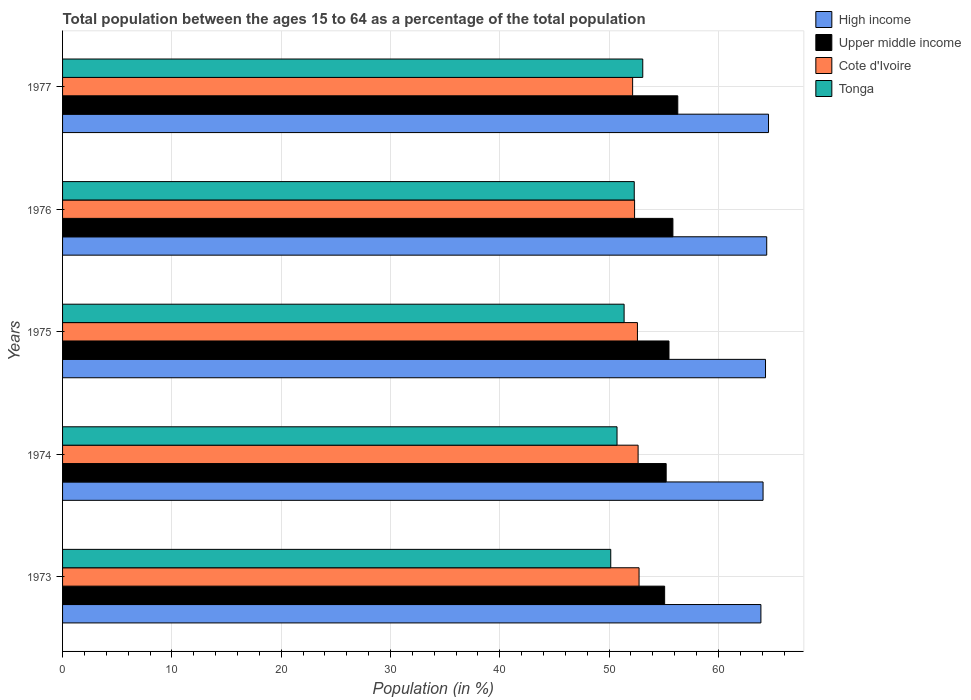How many different coloured bars are there?
Ensure brevity in your answer.  4. How many groups of bars are there?
Keep it short and to the point. 5. Are the number of bars on each tick of the Y-axis equal?
Your answer should be compact. Yes. How many bars are there on the 2nd tick from the top?
Your response must be concise. 4. How many bars are there on the 3rd tick from the bottom?
Your answer should be very brief. 4. What is the label of the 3rd group of bars from the top?
Offer a terse response. 1975. What is the percentage of the population ages 15 to 64 in High income in 1973?
Offer a terse response. 63.89. Across all years, what is the maximum percentage of the population ages 15 to 64 in Cote d'Ivoire?
Your answer should be very brief. 52.74. Across all years, what is the minimum percentage of the population ages 15 to 64 in Cote d'Ivoire?
Give a very brief answer. 52.15. In which year was the percentage of the population ages 15 to 64 in Tonga maximum?
Make the answer very short. 1977. What is the total percentage of the population ages 15 to 64 in High income in the graph?
Give a very brief answer. 321.27. What is the difference between the percentage of the population ages 15 to 64 in Tonga in 1975 and that in 1977?
Your answer should be compact. -1.71. What is the difference between the percentage of the population ages 15 to 64 in Upper middle income in 1973 and the percentage of the population ages 15 to 64 in Cote d'Ivoire in 1976?
Provide a succinct answer. 2.75. What is the average percentage of the population ages 15 to 64 in Upper middle income per year?
Make the answer very short. 55.58. In the year 1975, what is the difference between the percentage of the population ages 15 to 64 in High income and percentage of the population ages 15 to 64 in Tonga?
Offer a very short reply. 12.94. In how many years, is the percentage of the population ages 15 to 64 in Upper middle income greater than 46 ?
Offer a terse response. 5. What is the ratio of the percentage of the population ages 15 to 64 in High income in 1973 to that in 1976?
Provide a succinct answer. 0.99. Is the percentage of the population ages 15 to 64 in Tonga in 1973 less than that in 1974?
Provide a succinct answer. Yes. What is the difference between the highest and the second highest percentage of the population ages 15 to 64 in High income?
Your response must be concise. 0.16. What is the difference between the highest and the lowest percentage of the population ages 15 to 64 in High income?
Provide a short and direct response. 0.7. In how many years, is the percentage of the population ages 15 to 64 in Cote d'Ivoire greater than the average percentage of the population ages 15 to 64 in Cote d'Ivoire taken over all years?
Keep it short and to the point. 3. Is the sum of the percentage of the population ages 15 to 64 in High income in 1973 and 1977 greater than the maximum percentage of the population ages 15 to 64 in Cote d'Ivoire across all years?
Your response must be concise. Yes. What does the 1st bar from the top in 1976 represents?
Ensure brevity in your answer.  Tonga. What does the 4th bar from the bottom in 1976 represents?
Give a very brief answer. Tonga. How many bars are there?
Provide a succinct answer. 20. Are the values on the major ticks of X-axis written in scientific E-notation?
Provide a short and direct response. No. Does the graph contain any zero values?
Ensure brevity in your answer.  No. Does the graph contain grids?
Offer a terse response. Yes. How are the legend labels stacked?
Make the answer very short. Vertical. What is the title of the graph?
Your answer should be compact. Total population between the ages 15 to 64 as a percentage of the total population. What is the label or title of the X-axis?
Offer a terse response. Population (in %). What is the Population (in %) in High income in 1973?
Your answer should be compact. 63.89. What is the Population (in %) of Upper middle income in 1973?
Offer a terse response. 55.08. What is the Population (in %) of Cote d'Ivoire in 1973?
Offer a terse response. 52.74. What is the Population (in %) in Tonga in 1973?
Keep it short and to the point. 50.15. What is the Population (in %) of High income in 1974?
Make the answer very short. 64.08. What is the Population (in %) of Upper middle income in 1974?
Your answer should be compact. 55.22. What is the Population (in %) in Cote d'Ivoire in 1974?
Offer a terse response. 52.65. What is the Population (in %) in Tonga in 1974?
Provide a succinct answer. 50.72. What is the Population (in %) of High income in 1975?
Ensure brevity in your answer.  64.31. What is the Population (in %) of Upper middle income in 1975?
Your answer should be compact. 55.48. What is the Population (in %) of Cote d'Ivoire in 1975?
Your response must be concise. 52.59. What is the Population (in %) in Tonga in 1975?
Make the answer very short. 51.37. What is the Population (in %) in High income in 1976?
Your answer should be very brief. 64.42. What is the Population (in %) in Upper middle income in 1976?
Your response must be concise. 55.83. What is the Population (in %) of Cote d'Ivoire in 1976?
Make the answer very short. 52.33. What is the Population (in %) in Tonga in 1976?
Provide a succinct answer. 52.3. What is the Population (in %) of High income in 1977?
Ensure brevity in your answer.  64.58. What is the Population (in %) in Upper middle income in 1977?
Your answer should be very brief. 56.28. What is the Population (in %) in Cote d'Ivoire in 1977?
Provide a succinct answer. 52.15. What is the Population (in %) in Tonga in 1977?
Make the answer very short. 53.08. Across all years, what is the maximum Population (in %) of High income?
Keep it short and to the point. 64.58. Across all years, what is the maximum Population (in %) in Upper middle income?
Your response must be concise. 56.28. Across all years, what is the maximum Population (in %) in Cote d'Ivoire?
Offer a terse response. 52.74. Across all years, what is the maximum Population (in %) of Tonga?
Keep it short and to the point. 53.08. Across all years, what is the minimum Population (in %) of High income?
Make the answer very short. 63.89. Across all years, what is the minimum Population (in %) in Upper middle income?
Provide a succinct answer. 55.08. Across all years, what is the minimum Population (in %) in Cote d'Ivoire?
Give a very brief answer. 52.15. Across all years, what is the minimum Population (in %) in Tonga?
Provide a short and direct response. 50.15. What is the total Population (in %) of High income in the graph?
Provide a short and direct response. 321.27. What is the total Population (in %) of Upper middle income in the graph?
Your answer should be very brief. 277.89. What is the total Population (in %) of Cote d'Ivoire in the graph?
Keep it short and to the point. 262.46. What is the total Population (in %) in Tonga in the graph?
Make the answer very short. 257.62. What is the difference between the Population (in %) in High income in 1973 and that in 1974?
Your answer should be very brief. -0.2. What is the difference between the Population (in %) of Upper middle income in 1973 and that in 1974?
Your answer should be compact. -0.14. What is the difference between the Population (in %) in Cote d'Ivoire in 1973 and that in 1974?
Ensure brevity in your answer.  0.09. What is the difference between the Population (in %) of Tonga in 1973 and that in 1974?
Provide a succinct answer. -0.57. What is the difference between the Population (in %) of High income in 1973 and that in 1975?
Provide a short and direct response. -0.42. What is the difference between the Population (in %) of Upper middle income in 1973 and that in 1975?
Provide a succinct answer. -0.4. What is the difference between the Population (in %) of Cote d'Ivoire in 1973 and that in 1975?
Provide a succinct answer. 0.15. What is the difference between the Population (in %) in Tonga in 1973 and that in 1975?
Your response must be concise. -1.22. What is the difference between the Population (in %) in High income in 1973 and that in 1976?
Ensure brevity in your answer.  -0.53. What is the difference between the Population (in %) of Upper middle income in 1973 and that in 1976?
Your answer should be compact. -0.76. What is the difference between the Population (in %) of Cote d'Ivoire in 1973 and that in 1976?
Provide a short and direct response. 0.41. What is the difference between the Population (in %) in Tonga in 1973 and that in 1976?
Your answer should be very brief. -2.15. What is the difference between the Population (in %) of High income in 1973 and that in 1977?
Give a very brief answer. -0.7. What is the difference between the Population (in %) of Upper middle income in 1973 and that in 1977?
Provide a short and direct response. -1.2. What is the difference between the Population (in %) in Cote d'Ivoire in 1973 and that in 1977?
Offer a very short reply. 0.59. What is the difference between the Population (in %) of Tonga in 1973 and that in 1977?
Ensure brevity in your answer.  -2.93. What is the difference between the Population (in %) in High income in 1974 and that in 1975?
Your answer should be very brief. -0.22. What is the difference between the Population (in %) in Upper middle income in 1974 and that in 1975?
Keep it short and to the point. -0.26. What is the difference between the Population (in %) in Cote d'Ivoire in 1974 and that in 1975?
Ensure brevity in your answer.  0.06. What is the difference between the Population (in %) of Tonga in 1974 and that in 1975?
Provide a succinct answer. -0.65. What is the difference between the Population (in %) of High income in 1974 and that in 1976?
Your response must be concise. -0.33. What is the difference between the Population (in %) in Upper middle income in 1974 and that in 1976?
Offer a terse response. -0.62. What is the difference between the Population (in %) in Cote d'Ivoire in 1974 and that in 1976?
Offer a terse response. 0.32. What is the difference between the Population (in %) in Tonga in 1974 and that in 1976?
Your answer should be very brief. -1.58. What is the difference between the Population (in %) in High income in 1974 and that in 1977?
Provide a succinct answer. -0.5. What is the difference between the Population (in %) in Upper middle income in 1974 and that in 1977?
Give a very brief answer. -1.06. What is the difference between the Population (in %) of Cote d'Ivoire in 1974 and that in 1977?
Your answer should be very brief. 0.5. What is the difference between the Population (in %) of Tonga in 1974 and that in 1977?
Ensure brevity in your answer.  -2.35. What is the difference between the Population (in %) in High income in 1975 and that in 1976?
Give a very brief answer. -0.11. What is the difference between the Population (in %) of Upper middle income in 1975 and that in 1976?
Your answer should be very brief. -0.36. What is the difference between the Population (in %) in Cote d'Ivoire in 1975 and that in 1976?
Provide a short and direct response. 0.26. What is the difference between the Population (in %) of Tonga in 1975 and that in 1976?
Provide a short and direct response. -0.93. What is the difference between the Population (in %) in High income in 1975 and that in 1977?
Make the answer very short. -0.28. What is the difference between the Population (in %) in Upper middle income in 1975 and that in 1977?
Provide a succinct answer. -0.81. What is the difference between the Population (in %) of Cote d'Ivoire in 1975 and that in 1977?
Your answer should be very brief. 0.44. What is the difference between the Population (in %) of Tonga in 1975 and that in 1977?
Your answer should be very brief. -1.71. What is the difference between the Population (in %) in High income in 1976 and that in 1977?
Offer a very short reply. -0.16. What is the difference between the Population (in %) of Upper middle income in 1976 and that in 1977?
Your answer should be compact. -0.45. What is the difference between the Population (in %) in Cote d'Ivoire in 1976 and that in 1977?
Your answer should be very brief. 0.18. What is the difference between the Population (in %) of Tonga in 1976 and that in 1977?
Make the answer very short. -0.78. What is the difference between the Population (in %) of High income in 1973 and the Population (in %) of Upper middle income in 1974?
Keep it short and to the point. 8.67. What is the difference between the Population (in %) of High income in 1973 and the Population (in %) of Cote d'Ivoire in 1974?
Offer a terse response. 11.23. What is the difference between the Population (in %) in High income in 1973 and the Population (in %) in Tonga in 1974?
Make the answer very short. 13.16. What is the difference between the Population (in %) in Upper middle income in 1973 and the Population (in %) in Cote d'Ivoire in 1974?
Provide a succinct answer. 2.43. What is the difference between the Population (in %) in Upper middle income in 1973 and the Population (in %) in Tonga in 1974?
Make the answer very short. 4.36. What is the difference between the Population (in %) in Cote d'Ivoire in 1973 and the Population (in %) in Tonga in 1974?
Offer a terse response. 2.02. What is the difference between the Population (in %) of High income in 1973 and the Population (in %) of Upper middle income in 1975?
Keep it short and to the point. 8.41. What is the difference between the Population (in %) of High income in 1973 and the Population (in %) of Cote d'Ivoire in 1975?
Provide a short and direct response. 11.3. What is the difference between the Population (in %) of High income in 1973 and the Population (in %) of Tonga in 1975?
Your answer should be compact. 12.51. What is the difference between the Population (in %) in Upper middle income in 1973 and the Population (in %) in Cote d'Ivoire in 1975?
Make the answer very short. 2.49. What is the difference between the Population (in %) of Upper middle income in 1973 and the Population (in %) of Tonga in 1975?
Make the answer very short. 3.71. What is the difference between the Population (in %) in Cote d'Ivoire in 1973 and the Population (in %) in Tonga in 1975?
Your answer should be compact. 1.37. What is the difference between the Population (in %) in High income in 1973 and the Population (in %) in Upper middle income in 1976?
Give a very brief answer. 8.05. What is the difference between the Population (in %) of High income in 1973 and the Population (in %) of Cote d'Ivoire in 1976?
Give a very brief answer. 11.56. What is the difference between the Population (in %) of High income in 1973 and the Population (in %) of Tonga in 1976?
Your answer should be very brief. 11.59. What is the difference between the Population (in %) in Upper middle income in 1973 and the Population (in %) in Cote d'Ivoire in 1976?
Your response must be concise. 2.75. What is the difference between the Population (in %) in Upper middle income in 1973 and the Population (in %) in Tonga in 1976?
Offer a very short reply. 2.78. What is the difference between the Population (in %) in Cote d'Ivoire in 1973 and the Population (in %) in Tonga in 1976?
Offer a terse response. 0.44. What is the difference between the Population (in %) of High income in 1973 and the Population (in %) of Upper middle income in 1977?
Provide a short and direct response. 7.6. What is the difference between the Population (in %) in High income in 1973 and the Population (in %) in Cote d'Ivoire in 1977?
Keep it short and to the point. 11.74. What is the difference between the Population (in %) in High income in 1973 and the Population (in %) in Tonga in 1977?
Your answer should be compact. 10.81. What is the difference between the Population (in %) in Upper middle income in 1973 and the Population (in %) in Cote d'Ivoire in 1977?
Your answer should be compact. 2.93. What is the difference between the Population (in %) in Upper middle income in 1973 and the Population (in %) in Tonga in 1977?
Give a very brief answer. 2. What is the difference between the Population (in %) of Cote d'Ivoire in 1973 and the Population (in %) of Tonga in 1977?
Your answer should be compact. -0.34. What is the difference between the Population (in %) in High income in 1974 and the Population (in %) in Upper middle income in 1975?
Keep it short and to the point. 8.61. What is the difference between the Population (in %) in High income in 1974 and the Population (in %) in Cote d'Ivoire in 1975?
Ensure brevity in your answer.  11.49. What is the difference between the Population (in %) of High income in 1974 and the Population (in %) of Tonga in 1975?
Make the answer very short. 12.71. What is the difference between the Population (in %) in Upper middle income in 1974 and the Population (in %) in Cote d'Ivoire in 1975?
Provide a short and direct response. 2.63. What is the difference between the Population (in %) of Upper middle income in 1974 and the Population (in %) of Tonga in 1975?
Make the answer very short. 3.85. What is the difference between the Population (in %) of Cote d'Ivoire in 1974 and the Population (in %) of Tonga in 1975?
Your answer should be compact. 1.28. What is the difference between the Population (in %) in High income in 1974 and the Population (in %) in Upper middle income in 1976?
Provide a short and direct response. 8.25. What is the difference between the Population (in %) of High income in 1974 and the Population (in %) of Cote d'Ivoire in 1976?
Provide a succinct answer. 11.75. What is the difference between the Population (in %) of High income in 1974 and the Population (in %) of Tonga in 1976?
Give a very brief answer. 11.78. What is the difference between the Population (in %) in Upper middle income in 1974 and the Population (in %) in Cote d'Ivoire in 1976?
Your answer should be compact. 2.89. What is the difference between the Population (in %) in Upper middle income in 1974 and the Population (in %) in Tonga in 1976?
Your answer should be compact. 2.92. What is the difference between the Population (in %) in Cote d'Ivoire in 1974 and the Population (in %) in Tonga in 1976?
Give a very brief answer. 0.35. What is the difference between the Population (in %) in High income in 1974 and the Population (in %) in Upper middle income in 1977?
Provide a succinct answer. 7.8. What is the difference between the Population (in %) in High income in 1974 and the Population (in %) in Cote d'Ivoire in 1977?
Keep it short and to the point. 11.93. What is the difference between the Population (in %) in High income in 1974 and the Population (in %) in Tonga in 1977?
Keep it short and to the point. 11.01. What is the difference between the Population (in %) of Upper middle income in 1974 and the Population (in %) of Cote d'Ivoire in 1977?
Offer a very short reply. 3.07. What is the difference between the Population (in %) of Upper middle income in 1974 and the Population (in %) of Tonga in 1977?
Keep it short and to the point. 2.14. What is the difference between the Population (in %) in Cote d'Ivoire in 1974 and the Population (in %) in Tonga in 1977?
Provide a short and direct response. -0.43. What is the difference between the Population (in %) of High income in 1975 and the Population (in %) of Upper middle income in 1976?
Make the answer very short. 8.47. What is the difference between the Population (in %) in High income in 1975 and the Population (in %) in Cote d'Ivoire in 1976?
Make the answer very short. 11.98. What is the difference between the Population (in %) in High income in 1975 and the Population (in %) in Tonga in 1976?
Give a very brief answer. 12.01. What is the difference between the Population (in %) of Upper middle income in 1975 and the Population (in %) of Cote d'Ivoire in 1976?
Offer a very short reply. 3.15. What is the difference between the Population (in %) in Upper middle income in 1975 and the Population (in %) in Tonga in 1976?
Offer a very short reply. 3.18. What is the difference between the Population (in %) of Cote d'Ivoire in 1975 and the Population (in %) of Tonga in 1976?
Give a very brief answer. 0.29. What is the difference between the Population (in %) of High income in 1975 and the Population (in %) of Upper middle income in 1977?
Your answer should be compact. 8.03. What is the difference between the Population (in %) of High income in 1975 and the Population (in %) of Cote d'Ivoire in 1977?
Your response must be concise. 12.16. What is the difference between the Population (in %) in High income in 1975 and the Population (in %) in Tonga in 1977?
Provide a succinct answer. 11.23. What is the difference between the Population (in %) in Upper middle income in 1975 and the Population (in %) in Cote d'Ivoire in 1977?
Offer a terse response. 3.33. What is the difference between the Population (in %) of Upper middle income in 1975 and the Population (in %) of Tonga in 1977?
Give a very brief answer. 2.4. What is the difference between the Population (in %) in Cote d'Ivoire in 1975 and the Population (in %) in Tonga in 1977?
Offer a very short reply. -0.49. What is the difference between the Population (in %) in High income in 1976 and the Population (in %) in Upper middle income in 1977?
Offer a terse response. 8.14. What is the difference between the Population (in %) of High income in 1976 and the Population (in %) of Cote d'Ivoire in 1977?
Keep it short and to the point. 12.27. What is the difference between the Population (in %) in High income in 1976 and the Population (in %) in Tonga in 1977?
Ensure brevity in your answer.  11.34. What is the difference between the Population (in %) in Upper middle income in 1976 and the Population (in %) in Cote d'Ivoire in 1977?
Offer a terse response. 3.69. What is the difference between the Population (in %) of Upper middle income in 1976 and the Population (in %) of Tonga in 1977?
Your answer should be compact. 2.76. What is the difference between the Population (in %) in Cote d'Ivoire in 1976 and the Population (in %) in Tonga in 1977?
Provide a short and direct response. -0.75. What is the average Population (in %) in High income per year?
Provide a short and direct response. 64.25. What is the average Population (in %) of Upper middle income per year?
Provide a short and direct response. 55.58. What is the average Population (in %) of Cote d'Ivoire per year?
Offer a very short reply. 52.49. What is the average Population (in %) in Tonga per year?
Ensure brevity in your answer.  51.52. In the year 1973, what is the difference between the Population (in %) in High income and Population (in %) in Upper middle income?
Offer a very short reply. 8.81. In the year 1973, what is the difference between the Population (in %) in High income and Population (in %) in Cote d'Ivoire?
Provide a short and direct response. 11.15. In the year 1973, what is the difference between the Population (in %) in High income and Population (in %) in Tonga?
Provide a short and direct response. 13.74. In the year 1973, what is the difference between the Population (in %) in Upper middle income and Population (in %) in Cote d'Ivoire?
Your answer should be compact. 2.34. In the year 1973, what is the difference between the Population (in %) of Upper middle income and Population (in %) of Tonga?
Offer a terse response. 4.93. In the year 1973, what is the difference between the Population (in %) in Cote d'Ivoire and Population (in %) in Tonga?
Give a very brief answer. 2.59. In the year 1974, what is the difference between the Population (in %) of High income and Population (in %) of Upper middle income?
Provide a succinct answer. 8.86. In the year 1974, what is the difference between the Population (in %) of High income and Population (in %) of Cote d'Ivoire?
Keep it short and to the point. 11.43. In the year 1974, what is the difference between the Population (in %) of High income and Population (in %) of Tonga?
Your answer should be compact. 13.36. In the year 1974, what is the difference between the Population (in %) of Upper middle income and Population (in %) of Cote d'Ivoire?
Your answer should be very brief. 2.57. In the year 1974, what is the difference between the Population (in %) in Upper middle income and Population (in %) in Tonga?
Offer a very short reply. 4.5. In the year 1974, what is the difference between the Population (in %) of Cote d'Ivoire and Population (in %) of Tonga?
Your response must be concise. 1.93. In the year 1975, what is the difference between the Population (in %) in High income and Population (in %) in Upper middle income?
Provide a succinct answer. 8.83. In the year 1975, what is the difference between the Population (in %) in High income and Population (in %) in Cote d'Ivoire?
Your answer should be very brief. 11.72. In the year 1975, what is the difference between the Population (in %) in High income and Population (in %) in Tonga?
Keep it short and to the point. 12.94. In the year 1975, what is the difference between the Population (in %) in Upper middle income and Population (in %) in Cote d'Ivoire?
Give a very brief answer. 2.89. In the year 1975, what is the difference between the Population (in %) of Upper middle income and Population (in %) of Tonga?
Offer a terse response. 4.1. In the year 1975, what is the difference between the Population (in %) in Cote d'Ivoire and Population (in %) in Tonga?
Your response must be concise. 1.22. In the year 1976, what is the difference between the Population (in %) in High income and Population (in %) in Upper middle income?
Give a very brief answer. 8.58. In the year 1976, what is the difference between the Population (in %) in High income and Population (in %) in Cote d'Ivoire?
Your answer should be very brief. 12.09. In the year 1976, what is the difference between the Population (in %) in High income and Population (in %) in Tonga?
Keep it short and to the point. 12.12. In the year 1976, what is the difference between the Population (in %) of Upper middle income and Population (in %) of Cote d'Ivoire?
Provide a short and direct response. 3.51. In the year 1976, what is the difference between the Population (in %) in Upper middle income and Population (in %) in Tonga?
Offer a terse response. 3.54. In the year 1976, what is the difference between the Population (in %) in Cote d'Ivoire and Population (in %) in Tonga?
Give a very brief answer. 0.03. In the year 1977, what is the difference between the Population (in %) in High income and Population (in %) in Upper middle income?
Give a very brief answer. 8.3. In the year 1977, what is the difference between the Population (in %) of High income and Population (in %) of Cote d'Ivoire?
Give a very brief answer. 12.43. In the year 1977, what is the difference between the Population (in %) of High income and Population (in %) of Tonga?
Your response must be concise. 11.5. In the year 1977, what is the difference between the Population (in %) of Upper middle income and Population (in %) of Cote d'Ivoire?
Keep it short and to the point. 4.13. In the year 1977, what is the difference between the Population (in %) of Upper middle income and Population (in %) of Tonga?
Your answer should be compact. 3.2. In the year 1977, what is the difference between the Population (in %) of Cote d'Ivoire and Population (in %) of Tonga?
Your answer should be very brief. -0.93. What is the ratio of the Population (in %) of High income in 1973 to that in 1974?
Provide a short and direct response. 1. What is the ratio of the Population (in %) in Upper middle income in 1973 to that in 1974?
Keep it short and to the point. 1. What is the ratio of the Population (in %) in Tonga in 1973 to that in 1974?
Make the answer very short. 0.99. What is the ratio of the Population (in %) in Upper middle income in 1973 to that in 1975?
Your response must be concise. 0.99. What is the ratio of the Population (in %) in Tonga in 1973 to that in 1975?
Give a very brief answer. 0.98. What is the ratio of the Population (in %) of High income in 1973 to that in 1976?
Your response must be concise. 0.99. What is the ratio of the Population (in %) of Upper middle income in 1973 to that in 1976?
Make the answer very short. 0.99. What is the ratio of the Population (in %) in Cote d'Ivoire in 1973 to that in 1976?
Your response must be concise. 1.01. What is the ratio of the Population (in %) of Tonga in 1973 to that in 1976?
Make the answer very short. 0.96. What is the ratio of the Population (in %) in High income in 1973 to that in 1977?
Your response must be concise. 0.99. What is the ratio of the Population (in %) in Upper middle income in 1973 to that in 1977?
Make the answer very short. 0.98. What is the ratio of the Population (in %) of Cote d'Ivoire in 1973 to that in 1977?
Give a very brief answer. 1.01. What is the ratio of the Population (in %) in Tonga in 1973 to that in 1977?
Keep it short and to the point. 0.94. What is the ratio of the Population (in %) in High income in 1974 to that in 1975?
Provide a succinct answer. 1. What is the ratio of the Population (in %) in Upper middle income in 1974 to that in 1975?
Keep it short and to the point. 1. What is the ratio of the Population (in %) of Cote d'Ivoire in 1974 to that in 1975?
Make the answer very short. 1. What is the ratio of the Population (in %) in Tonga in 1974 to that in 1975?
Ensure brevity in your answer.  0.99. What is the ratio of the Population (in %) in High income in 1974 to that in 1976?
Give a very brief answer. 0.99. What is the ratio of the Population (in %) of Tonga in 1974 to that in 1976?
Keep it short and to the point. 0.97. What is the ratio of the Population (in %) in High income in 1974 to that in 1977?
Offer a very short reply. 0.99. What is the ratio of the Population (in %) in Upper middle income in 1974 to that in 1977?
Offer a terse response. 0.98. What is the ratio of the Population (in %) of Cote d'Ivoire in 1974 to that in 1977?
Give a very brief answer. 1.01. What is the ratio of the Population (in %) in Tonga in 1974 to that in 1977?
Make the answer very short. 0.96. What is the ratio of the Population (in %) in High income in 1975 to that in 1976?
Provide a short and direct response. 1. What is the ratio of the Population (in %) of Upper middle income in 1975 to that in 1976?
Ensure brevity in your answer.  0.99. What is the ratio of the Population (in %) of Cote d'Ivoire in 1975 to that in 1976?
Provide a short and direct response. 1. What is the ratio of the Population (in %) in Tonga in 1975 to that in 1976?
Give a very brief answer. 0.98. What is the ratio of the Population (in %) of High income in 1975 to that in 1977?
Your answer should be compact. 1. What is the ratio of the Population (in %) of Upper middle income in 1975 to that in 1977?
Your response must be concise. 0.99. What is the ratio of the Population (in %) in Cote d'Ivoire in 1975 to that in 1977?
Give a very brief answer. 1.01. What is the ratio of the Population (in %) of Tonga in 1975 to that in 1977?
Your answer should be compact. 0.97. What is the ratio of the Population (in %) of High income in 1976 to that in 1977?
Your response must be concise. 1. What is the ratio of the Population (in %) of Cote d'Ivoire in 1976 to that in 1977?
Ensure brevity in your answer.  1. What is the difference between the highest and the second highest Population (in %) of High income?
Provide a succinct answer. 0.16. What is the difference between the highest and the second highest Population (in %) of Upper middle income?
Provide a succinct answer. 0.45. What is the difference between the highest and the second highest Population (in %) in Cote d'Ivoire?
Make the answer very short. 0.09. What is the difference between the highest and the second highest Population (in %) of Tonga?
Give a very brief answer. 0.78. What is the difference between the highest and the lowest Population (in %) in High income?
Offer a very short reply. 0.7. What is the difference between the highest and the lowest Population (in %) of Upper middle income?
Give a very brief answer. 1.2. What is the difference between the highest and the lowest Population (in %) in Cote d'Ivoire?
Your answer should be compact. 0.59. What is the difference between the highest and the lowest Population (in %) of Tonga?
Ensure brevity in your answer.  2.93. 